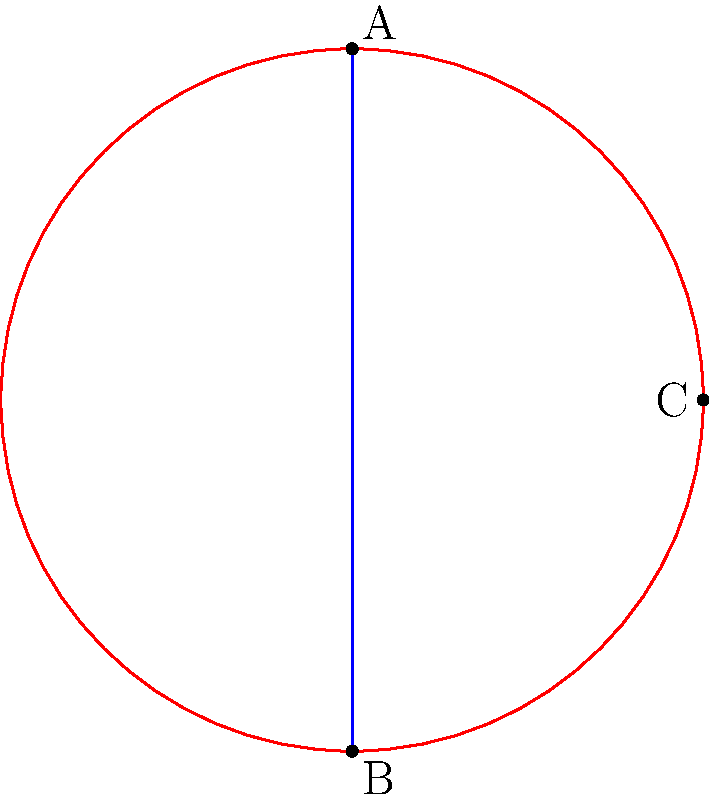In designing a navigation system for a virtual reality application, you need to implement the shortest path algorithm on a hyperbolic plane. Given two points A and B on the edge of a hyperbolic disk as shown in the figure, which path represents the shortest distance between these points in hyperbolic geometry? To determine the shortest path between two points on a hyperbolic plane, we need to consider the principles of hyperbolic geometry:

1. In hyperbolic geometry, the shortest path between two points is called a geodesic.

2. On a hyperbolic disk model (also known as the Poincaré disk model), geodesics are represented by either:
   a) Arcs of circles that intersect the boundary of the disk perpendicularly, or
   b) Straight lines passing through the center of the disk.

3. In the given figure:
   - The blue line represents a straight path between A and B.
   - The red path consists of two circular arcs that meet at point C on the boundary of the disk.

4. The red path is composed of arcs that intersect the boundary of the disk perpendicularly, making it a geodesic in hyperbolic geometry.

5. The blue straight line, while appearing shorter in Euclidean geometry, does not represent a geodesic in hyperbolic geometry unless it passes through the center of the disk (which it doesn't in this case).

6. Therefore, despite appearing longer in the Euclidean sense, the red path actually represents the shortest distance between points A and B in hyperbolic geometry.

This concept is crucial for implementing accurate navigation systems in virtual reality applications that simulate non-Euclidean spaces, ensuring that users can navigate efficiently and intuitively in these environments.
Answer: The red path (two circular arcs meeting at point C) 